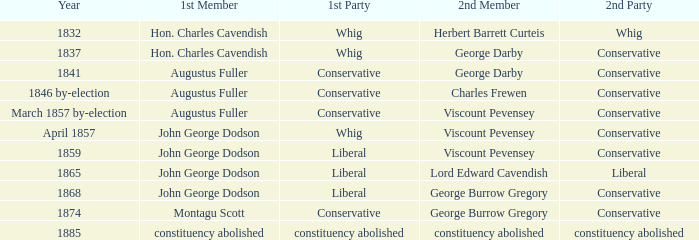In 1837, who was the 2nd member who's 2nd party was conservative. George Darby. 